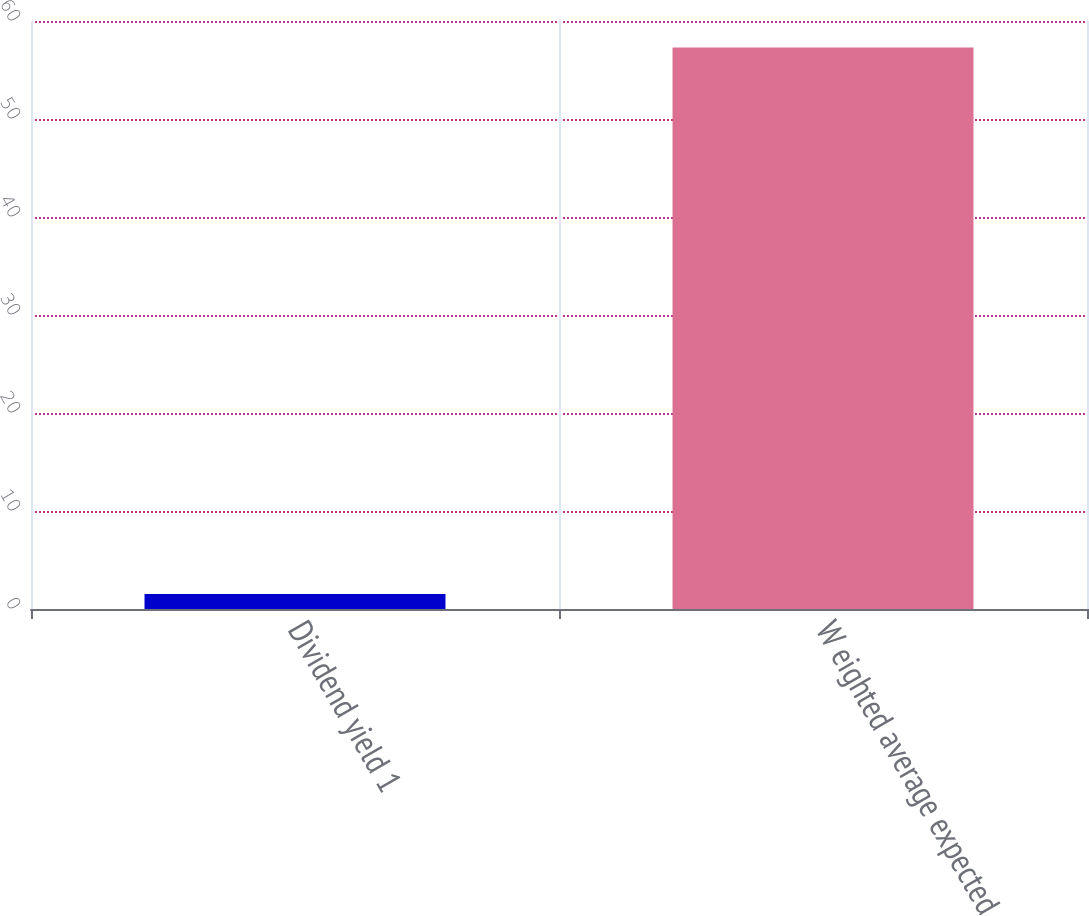Convert chart to OTSL. <chart><loc_0><loc_0><loc_500><loc_500><bar_chart><fcel>Dividend yield 1<fcel>W eighted average expected<nl><fcel>1.52<fcel>57.3<nl></chart> 